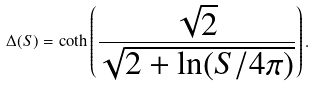<formula> <loc_0><loc_0><loc_500><loc_500>\Delta ( S ) = \coth \left ( \frac { \sqrt { 2 } } { \sqrt { 2 + \ln ( S / 4 \pi ) } } \right ) .</formula> 